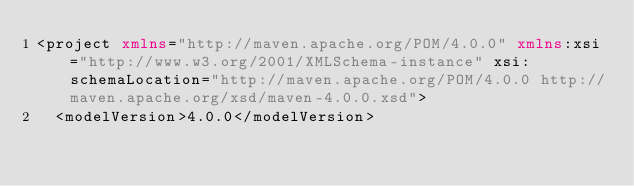Convert code to text. <code><loc_0><loc_0><loc_500><loc_500><_XML_><project xmlns="http://maven.apache.org/POM/4.0.0" xmlns:xsi="http://www.w3.org/2001/XMLSchema-instance" xsi:schemaLocation="http://maven.apache.org/POM/4.0.0 http://maven.apache.org/xsd/maven-4.0.0.xsd">
  <modelVersion>4.0.0</modelVersion></code> 